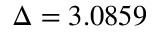<formula> <loc_0><loc_0><loc_500><loc_500>\Delta = 3 . 0 8 5 9</formula> 